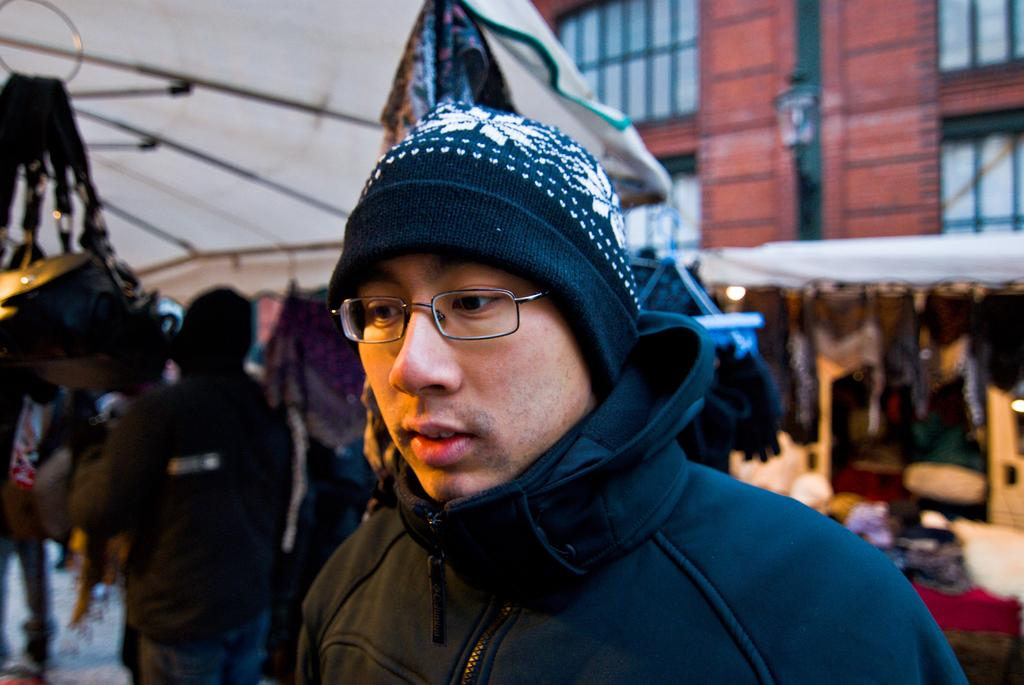Who or what is the main subject in the image? There is a person in the image. What can be seen in the distance behind the person? There is a building, stalls, and other people in the background of the image. Can you describe the setting of the image? The image appears to be set in an area with a building and stalls, suggesting it might be a market or fair. How many fairies are visible in the image? There are no fairies present in the image. What is the name of the person's son in the image? There is no information about a son in the image. 